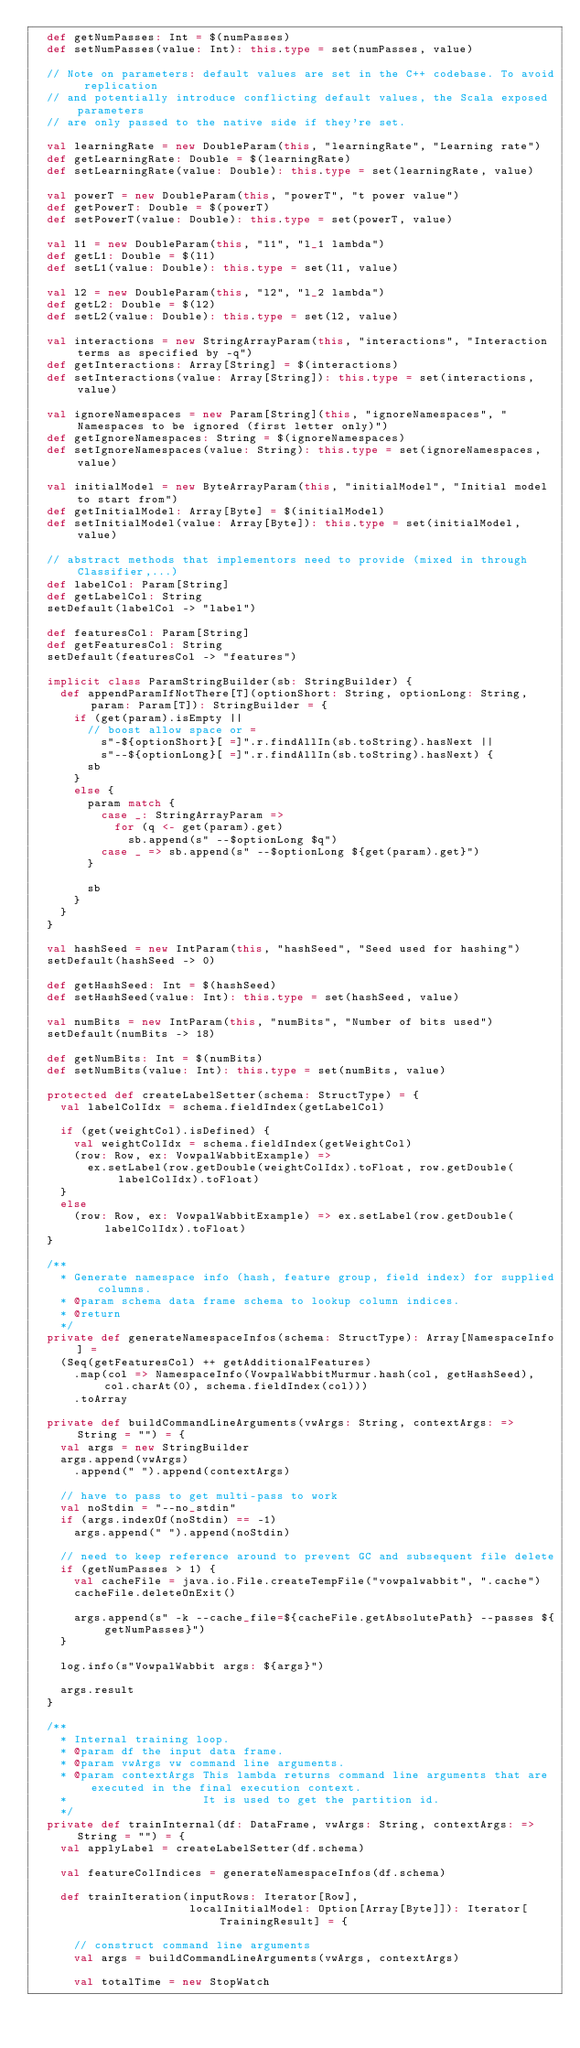<code> <loc_0><loc_0><loc_500><loc_500><_Scala_>  def getNumPasses: Int = $(numPasses)
  def setNumPasses(value: Int): this.type = set(numPasses, value)

  // Note on parameters: default values are set in the C++ codebase. To avoid replication
  // and potentially introduce conflicting default values, the Scala exposed parameters
  // are only passed to the native side if they're set.

  val learningRate = new DoubleParam(this, "learningRate", "Learning rate")
  def getLearningRate: Double = $(learningRate)
  def setLearningRate(value: Double): this.type = set(learningRate, value)

  val powerT = new DoubleParam(this, "powerT", "t power value")
  def getPowerT: Double = $(powerT)
  def setPowerT(value: Double): this.type = set(powerT, value)

  val l1 = new DoubleParam(this, "l1", "l_1 lambda")
  def getL1: Double = $(l1)
  def setL1(value: Double): this.type = set(l1, value)

  val l2 = new DoubleParam(this, "l2", "l_2 lambda")
  def getL2: Double = $(l2)
  def setL2(value: Double): this.type = set(l2, value)

  val interactions = new StringArrayParam(this, "interactions", "Interaction terms as specified by -q")
  def getInteractions: Array[String] = $(interactions)
  def setInteractions(value: Array[String]): this.type = set(interactions, value)

  val ignoreNamespaces = new Param[String](this, "ignoreNamespaces", "Namespaces to be ignored (first letter only)")
  def getIgnoreNamespaces: String = $(ignoreNamespaces)
  def setIgnoreNamespaces(value: String): this.type = set(ignoreNamespaces, value)

  val initialModel = new ByteArrayParam(this, "initialModel", "Initial model to start from")
  def getInitialModel: Array[Byte] = $(initialModel)
  def setInitialModel(value: Array[Byte]): this.type = set(initialModel, value)

  // abstract methods that implementors need to provide (mixed in through Classifier,...)
  def labelCol: Param[String]
  def getLabelCol: String
  setDefault(labelCol -> "label")

  def featuresCol: Param[String]
  def getFeaturesCol: String
  setDefault(featuresCol -> "features")

  implicit class ParamStringBuilder(sb: StringBuilder) {
    def appendParamIfNotThere[T](optionShort: String, optionLong: String, param: Param[T]): StringBuilder = {
      if (get(param).isEmpty ||
        // boost allow space or =
          s"-${optionShort}[ =]".r.findAllIn(sb.toString).hasNext ||
          s"--${optionLong}[ =]".r.findAllIn(sb.toString).hasNext) {
        sb
      }
      else {
        param match {
          case _: StringArrayParam =>
            for (q <- get(param).get)
              sb.append(s" --$optionLong $q")
          case _ => sb.append(s" --$optionLong ${get(param).get}")
        }

        sb
      }
    }
  }

  val hashSeed = new IntParam(this, "hashSeed", "Seed used for hashing")
  setDefault(hashSeed -> 0)

  def getHashSeed: Int = $(hashSeed)
  def setHashSeed(value: Int): this.type = set(hashSeed, value)

  val numBits = new IntParam(this, "numBits", "Number of bits used")
  setDefault(numBits -> 18)

  def getNumBits: Int = $(numBits)
  def setNumBits(value: Int): this.type = set(numBits, value)

  protected def createLabelSetter(schema: StructType) = {
    val labelColIdx = schema.fieldIndex(getLabelCol)

    if (get(weightCol).isDefined) {
      val weightColIdx = schema.fieldIndex(getWeightCol)
      (row: Row, ex: VowpalWabbitExample) =>
        ex.setLabel(row.getDouble(weightColIdx).toFloat, row.getDouble(labelColIdx).toFloat)
    }
    else
      (row: Row, ex: VowpalWabbitExample) => ex.setLabel(row.getDouble(labelColIdx).toFloat)
  }

  /**
    * Generate namespace info (hash, feature group, field index) for supplied columns.
    * @param schema data frame schema to lookup column indices.
    * @return
    */
  private def generateNamespaceInfos(schema: StructType): Array[NamespaceInfo] =
    (Seq(getFeaturesCol) ++ getAdditionalFeatures)
      .map(col => NamespaceInfo(VowpalWabbitMurmur.hash(col, getHashSeed), col.charAt(0), schema.fieldIndex(col)))
      .toArray

  private def buildCommandLineArguments(vwArgs: String, contextArgs: => String = "") = {
    val args = new StringBuilder
    args.append(vwArgs)
      .append(" ").append(contextArgs)

    // have to pass to get multi-pass to work
    val noStdin = "--no_stdin"
    if (args.indexOf(noStdin) == -1)
      args.append(" ").append(noStdin)

    // need to keep reference around to prevent GC and subsequent file delete
    if (getNumPasses > 1) {
      val cacheFile = java.io.File.createTempFile("vowpalwabbit", ".cache")
      cacheFile.deleteOnExit()

      args.append(s" -k --cache_file=${cacheFile.getAbsolutePath} --passes ${getNumPasses}")
    }

    log.info(s"VowpalWabbit args: ${args}")

    args.result
  }

  /**
    * Internal training loop.
    * @param df the input data frame.
    * @param vwArgs vw command line arguments.
    * @param contextArgs This lambda returns command line arguments that are executed in the final execution context.
    *                    It is used to get the partition id.
    */
  private def trainInternal(df: DataFrame, vwArgs: String, contextArgs: => String = "") = {
    val applyLabel = createLabelSetter(df.schema)

    val featureColIndices = generateNamespaceInfos(df.schema)

    def trainIteration(inputRows: Iterator[Row],
                       localInitialModel: Option[Array[Byte]]): Iterator[TrainingResult] = {

      // construct command line arguments
      val args = buildCommandLineArguments(vwArgs, contextArgs)

      val totalTime = new StopWatch</code> 